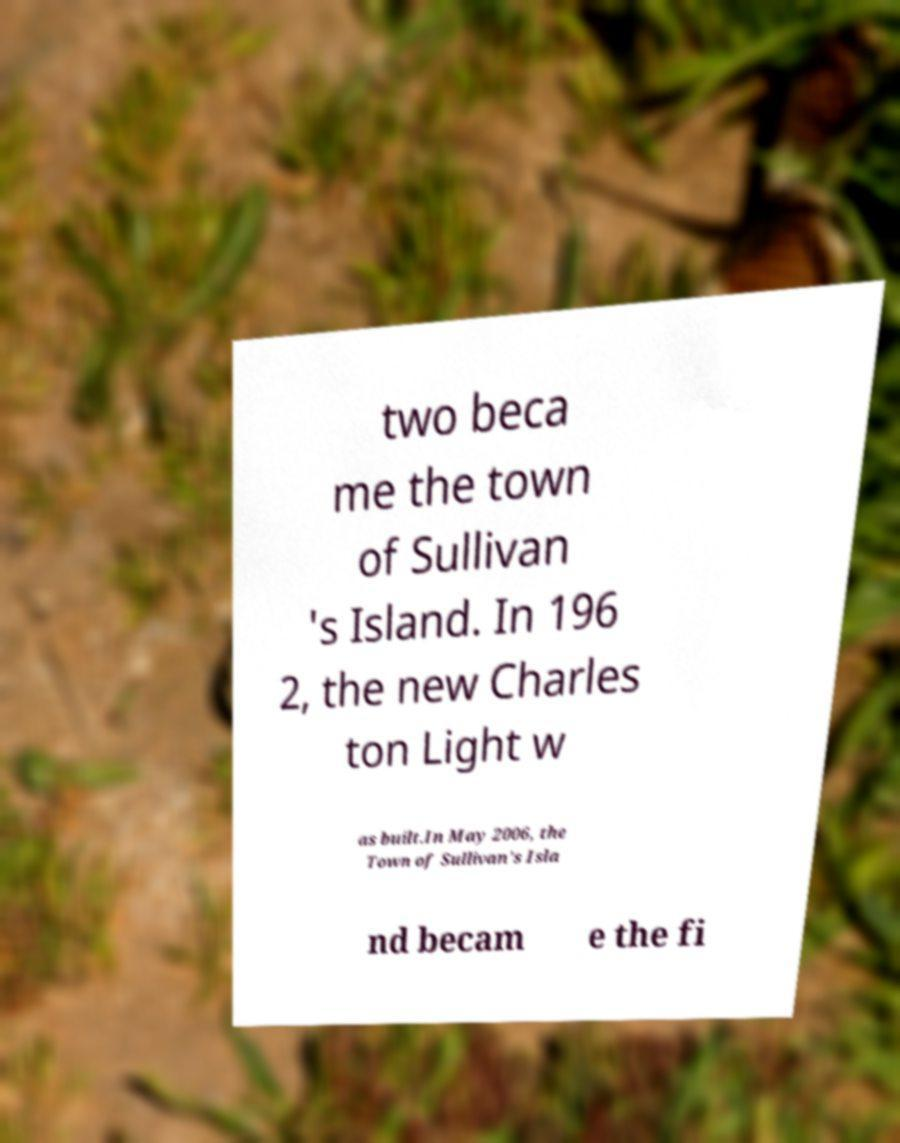For documentation purposes, I need the text within this image transcribed. Could you provide that? two beca me the town of Sullivan 's Island. In 196 2, the new Charles ton Light w as built.In May 2006, the Town of Sullivan's Isla nd becam e the fi 